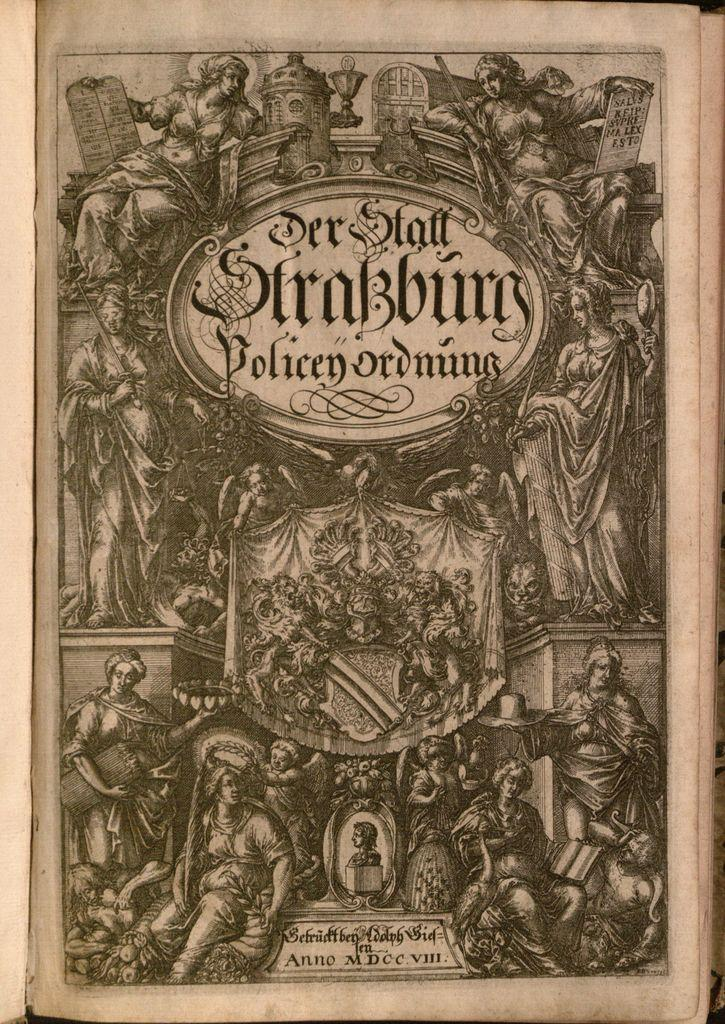<image>
Offer a succinct explanation of the picture presented. A book cover with the title Der Staff Srabburg has many statues on the cover. 